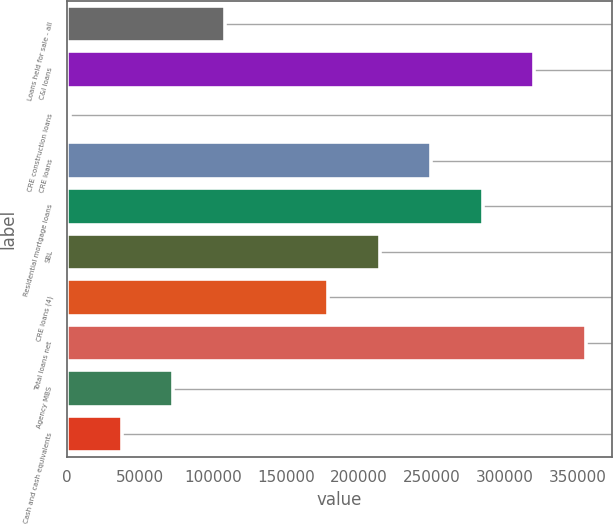Convert chart to OTSL. <chart><loc_0><loc_0><loc_500><loc_500><bar_chart><fcel>Loans held for sale - all<fcel>C&I loans<fcel>CRE construction loans<fcel>CRE loans<fcel>Residential mortgage loans<fcel>SBL<fcel>CRE loans (4)<fcel>Total loans net<fcel>Agency MBS<fcel>Cash and cash equivalents<nl><fcel>108233<fcel>320008<fcel>2346<fcel>249417<fcel>284712<fcel>214121<fcel>178825<fcel>355304<fcel>72937.6<fcel>37641.8<nl></chart> 